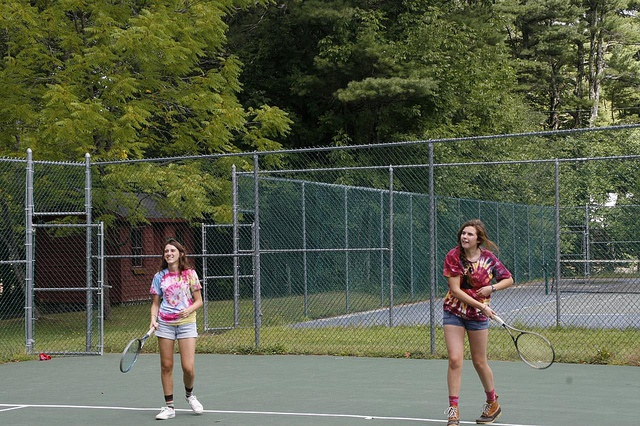Describe the objects in this image and their specific colors. I can see people in olive, brown, maroon, black, and darkgray tones, people in olive, lavender, brown, lightpink, and darkgray tones, tennis racket in olive, darkgray, gray, and black tones, and tennis racket in olive, gray, darkgray, and lightgray tones in this image. 